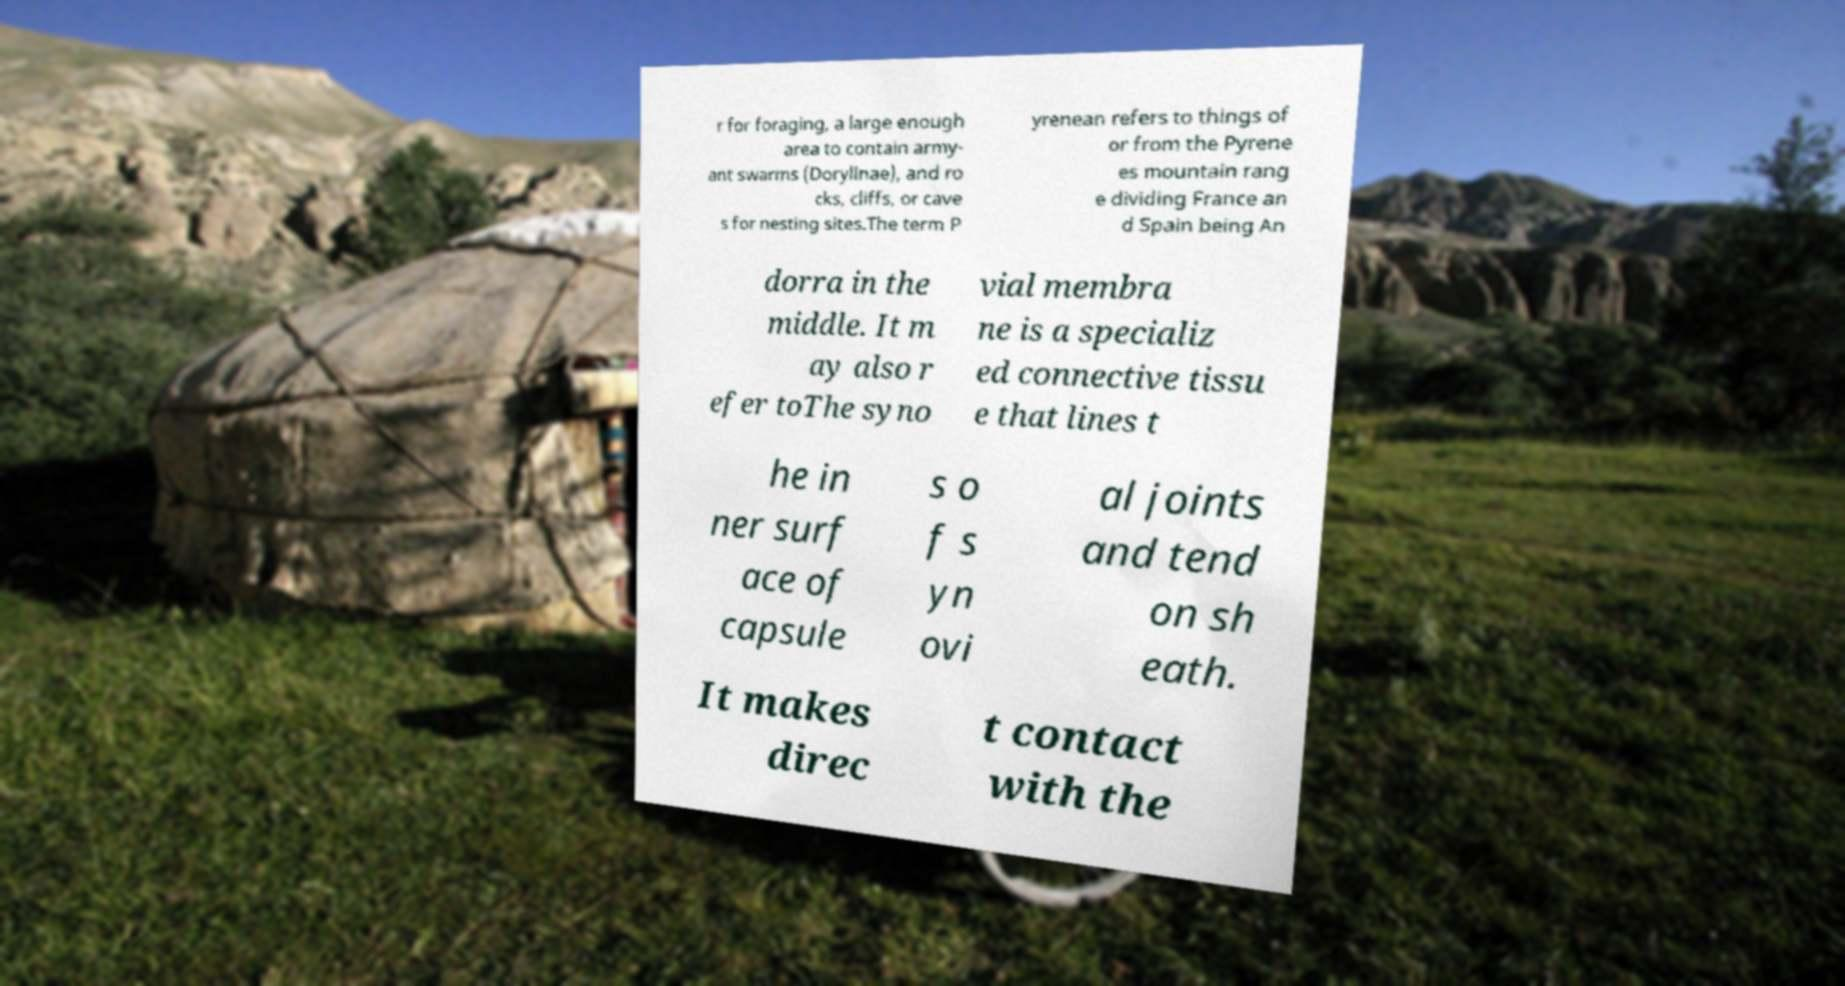Please identify and transcribe the text found in this image. r for foraging, a large enough area to contain army- ant swarms (Dorylinae), and ro cks, cliffs, or cave s for nesting sites.The term P yrenean refers to things of or from the Pyrene es mountain rang e dividing France an d Spain being An dorra in the middle. It m ay also r efer toThe syno vial membra ne is a specializ ed connective tissu e that lines t he in ner surf ace of capsule s o f s yn ovi al joints and tend on sh eath. It makes direc t contact with the 